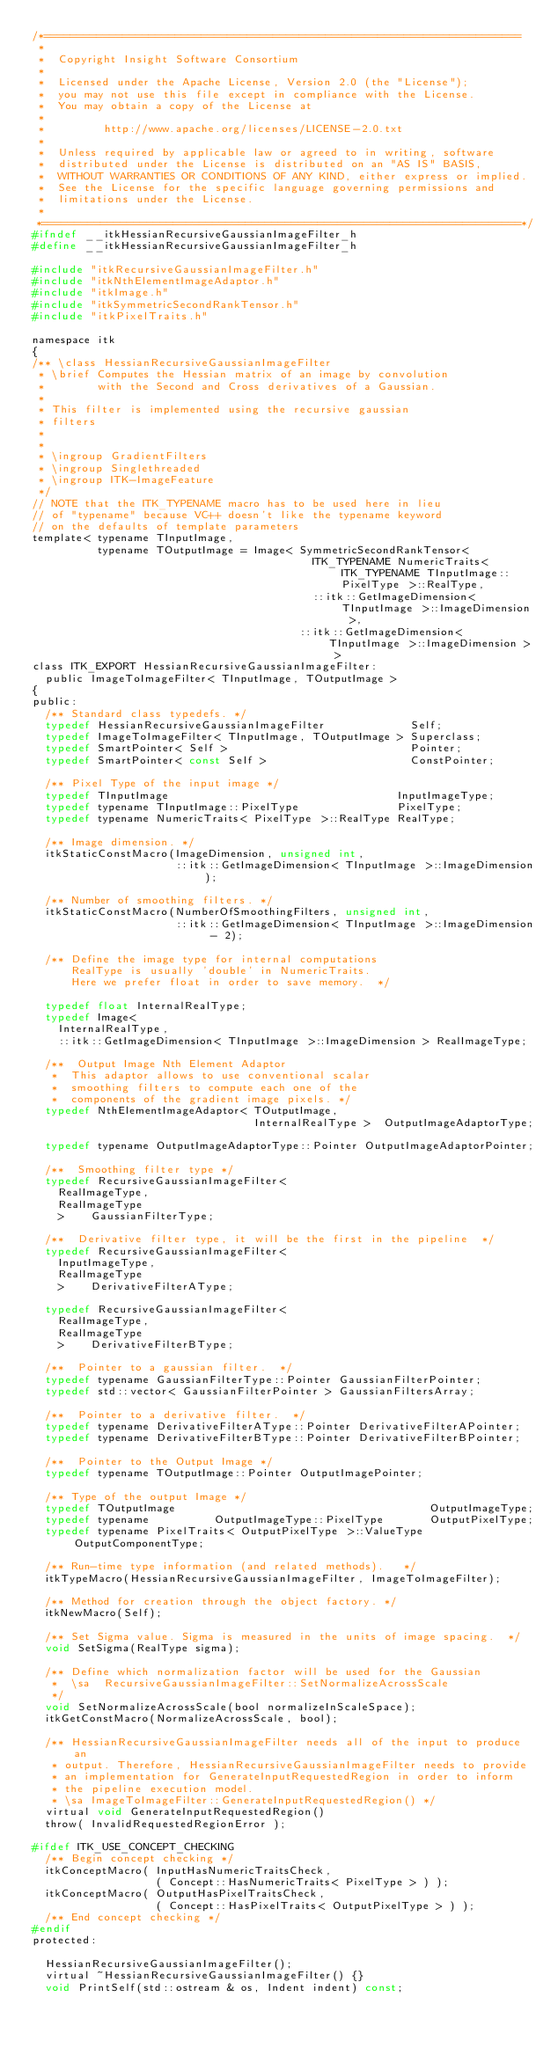Convert code to text. <code><loc_0><loc_0><loc_500><loc_500><_C_>/*=========================================================================
 *
 *  Copyright Insight Software Consortium
 *
 *  Licensed under the Apache License, Version 2.0 (the "License");
 *  you may not use this file except in compliance with the License.
 *  You may obtain a copy of the License at
 *
 *         http://www.apache.org/licenses/LICENSE-2.0.txt
 *
 *  Unless required by applicable law or agreed to in writing, software
 *  distributed under the License is distributed on an "AS IS" BASIS,
 *  WITHOUT WARRANTIES OR CONDITIONS OF ANY KIND, either express or implied.
 *  See the License for the specific language governing permissions and
 *  limitations under the License.
 *
 *=========================================================================*/
#ifndef __itkHessianRecursiveGaussianImageFilter_h
#define __itkHessianRecursiveGaussianImageFilter_h

#include "itkRecursiveGaussianImageFilter.h"
#include "itkNthElementImageAdaptor.h"
#include "itkImage.h"
#include "itkSymmetricSecondRankTensor.h"
#include "itkPixelTraits.h"

namespace itk
{
/** \class HessianRecursiveGaussianImageFilter
 * \brief Computes the Hessian matrix of an image by convolution
 *        with the Second and Cross derivatives of a Gaussian.
 *
 * This filter is implemented using the recursive gaussian
 * filters
 *
 *
 * \ingroup GradientFilters
 * \ingroup Singlethreaded
 * \ingroup ITK-ImageFeature
 */
// NOTE that the ITK_TYPENAME macro has to be used here in lieu
// of "typename" because VC++ doesn't like the typename keyword
// on the defaults of template parameters
template< typename TInputImage,
          typename TOutputImage = Image< SymmetricSecondRankTensor<
                                           ITK_TYPENAME NumericTraits< ITK_TYPENAME TInputImage::PixelType >::RealType,
                                           ::itk::GetImageDimension< TInputImage >::ImageDimension >,
                                         ::itk::GetImageDimension< TInputImage >::ImageDimension > >
class ITK_EXPORT HessianRecursiveGaussianImageFilter:
  public ImageToImageFilter< TInputImage, TOutputImage >
{
public:
  /** Standard class typedefs. */
  typedef HessianRecursiveGaussianImageFilter             Self;
  typedef ImageToImageFilter< TInputImage, TOutputImage > Superclass;
  typedef SmartPointer< Self >                            Pointer;
  typedef SmartPointer< const Self >                      ConstPointer;

  /** Pixel Type of the input image */
  typedef TInputImage                                   InputImageType;
  typedef typename TInputImage::PixelType               PixelType;
  typedef typename NumericTraits< PixelType >::RealType RealType;

  /** Image dimension. */
  itkStaticConstMacro(ImageDimension, unsigned int,
                      ::itk::GetImageDimension< TInputImage >::ImageDimension);

  /** Number of smoothing filters. */
  itkStaticConstMacro(NumberOfSmoothingFilters, unsigned int,
                      ::itk::GetImageDimension< TInputImage >::ImageDimension - 2);

  /** Define the image type for internal computations
      RealType is usually 'double' in NumericTraits.
      Here we prefer float in order to save memory.  */

  typedef float InternalRealType;
  typedef Image<
    InternalRealType,
    ::itk::GetImageDimension< TInputImage >::ImageDimension > RealImageType;

  /**  Output Image Nth Element Adaptor
   *  This adaptor allows to use conventional scalar
   *  smoothing filters to compute each one of the
   *  components of the gradient image pixels. */
  typedef NthElementImageAdaptor< TOutputImage,
                                  InternalRealType >  OutputImageAdaptorType;

  typedef typename OutputImageAdaptorType::Pointer OutputImageAdaptorPointer;

  /**  Smoothing filter type */
  typedef RecursiveGaussianImageFilter<
    RealImageType,
    RealImageType
    >    GaussianFilterType;

  /**  Derivative filter type, it will be the first in the pipeline  */
  typedef RecursiveGaussianImageFilter<
    InputImageType,
    RealImageType
    >    DerivativeFilterAType;

  typedef RecursiveGaussianImageFilter<
    RealImageType,
    RealImageType
    >    DerivativeFilterBType;

  /**  Pointer to a gaussian filter.  */
  typedef typename GaussianFilterType::Pointer GaussianFilterPointer;
  typedef std::vector< GaussianFilterPointer > GaussianFiltersArray;

  /**  Pointer to a derivative filter.  */
  typedef typename DerivativeFilterAType::Pointer DerivativeFilterAPointer;
  typedef typename DerivativeFilterBType::Pointer DerivativeFilterBPointer;

  /**  Pointer to the Output Image */
  typedef typename TOutputImage::Pointer OutputImagePointer;

  /** Type of the output Image */
  typedef TOutputImage                                       OutputImageType;
  typedef typename          OutputImageType::PixelType       OutputPixelType;
  typedef typename PixelTraits< OutputPixelType >::ValueType OutputComponentType;

  /** Run-time type information (and related methods).   */
  itkTypeMacro(HessianRecursiveGaussianImageFilter, ImageToImageFilter);

  /** Method for creation through the object factory. */
  itkNewMacro(Self);

  /** Set Sigma value. Sigma is measured in the units of image spacing.  */
  void SetSigma(RealType sigma);

  /** Define which normalization factor will be used for the Gaussian
   *  \sa  RecursiveGaussianImageFilter::SetNormalizeAcrossScale
   */
  void SetNormalizeAcrossScale(bool normalizeInScaleSpace);
  itkGetConstMacro(NormalizeAcrossScale, bool);

  /** HessianRecursiveGaussianImageFilter needs all of the input to produce an
   * output. Therefore, HessianRecursiveGaussianImageFilter needs to provide
   * an implementation for GenerateInputRequestedRegion in order to inform
   * the pipeline execution model.
   * \sa ImageToImageFilter::GenerateInputRequestedRegion() */
  virtual void GenerateInputRequestedRegion()
  throw( InvalidRequestedRegionError );

#ifdef ITK_USE_CONCEPT_CHECKING
  /** Begin concept checking */
  itkConceptMacro( InputHasNumericTraitsCheck,
                   ( Concept::HasNumericTraits< PixelType > ) );
  itkConceptMacro( OutputHasPixelTraitsCheck,
                   ( Concept::HasPixelTraits< OutputPixelType > ) );
  /** End concept checking */
#endif
protected:

  HessianRecursiveGaussianImageFilter();
  virtual ~HessianRecursiveGaussianImageFilter() {}
  void PrintSelf(std::ostream & os, Indent indent) const;
</code> 